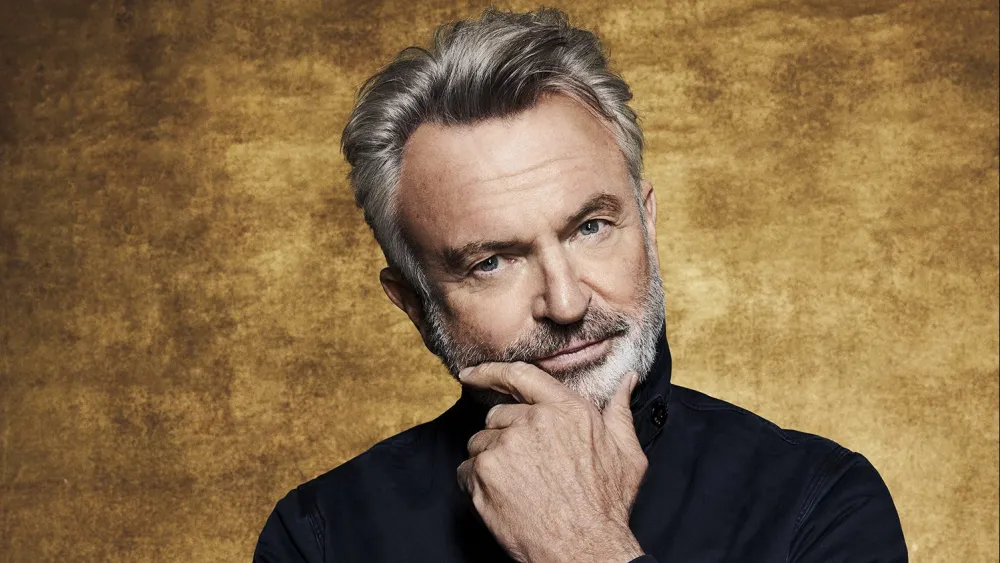Describe the mood conveyed by the subject in this image. The mood conveyed by the subject in this image is one of contemplative introspection and quiet confidence. The gentle smile suggests a sense of inner peace or amusement, while the thoughtful hand-on-chin gesture indicates deep thought or consideration. The warm gold background enhances this feeling by providing a serene and luxurious ambiance. Overall, the subject appears calm, confident, and reflective, creating a rich and engaging portrait. How might the subject's clothing contribute to the overall impression of the image? The subject’s choice of a black shirt adds a sense of elegance and sophistication to the image. Black is a timeless and powerful color that often conveys a sense of seriousness and thoughtfulness. In contrast with the gold background, the black shirt enhances the prominence of the subject, drawing the viewer’s attention to his thoughtful expression and pose. This sartorial choice complements the contemplative mood and reinforces the refined and polished nature of the image. Imagine the subject is pondering a monumental decision. What could this decision be? The subject might be pondering a monumental decision about embarking on a new and life-changing journey. Perhaps he is considering moving to a new country to start a fresh chapter in his life, leaving behind familiar surroundings for the promise of new opportunities and experiences. This decision could involve weighing personal growth and the potential for adventure against the comfort and security of the known. The contemplative expression hints at a moment of deep introspection, as he evaluates the pros and cons of this significant choice. 